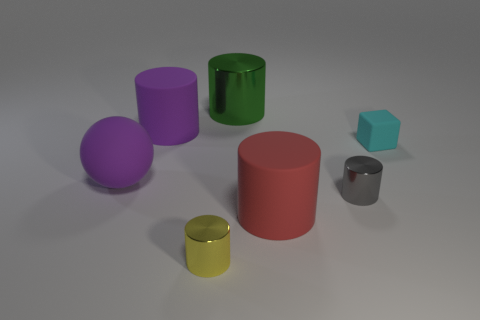How many purple objects are either rubber cylinders or large spheres?
Offer a very short reply. 2. What size is the rubber thing that is the same color as the matte sphere?
Your answer should be very brief. Large. Is the number of tiny rubber objects greater than the number of small yellow matte blocks?
Provide a short and direct response. Yes. Is the color of the big ball the same as the big shiny thing?
Your answer should be very brief. No. How many things are red rubber things or metal cylinders that are in front of the green shiny thing?
Your answer should be compact. 3. What number of other things are the same shape as the yellow object?
Keep it short and to the point. 4. Is the number of small yellow cylinders behind the cyan cube less than the number of gray shiny objects in front of the gray cylinder?
Your answer should be very brief. No. Is there anything else that is the same material as the yellow object?
Your answer should be very brief. Yes. What is the shape of the tiny thing that is made of the same material as the purple sphere?
Make the answer very short. Cube. Is there any other thing that is the same color as the cube?
Ensure brevity in your answer.  No. 